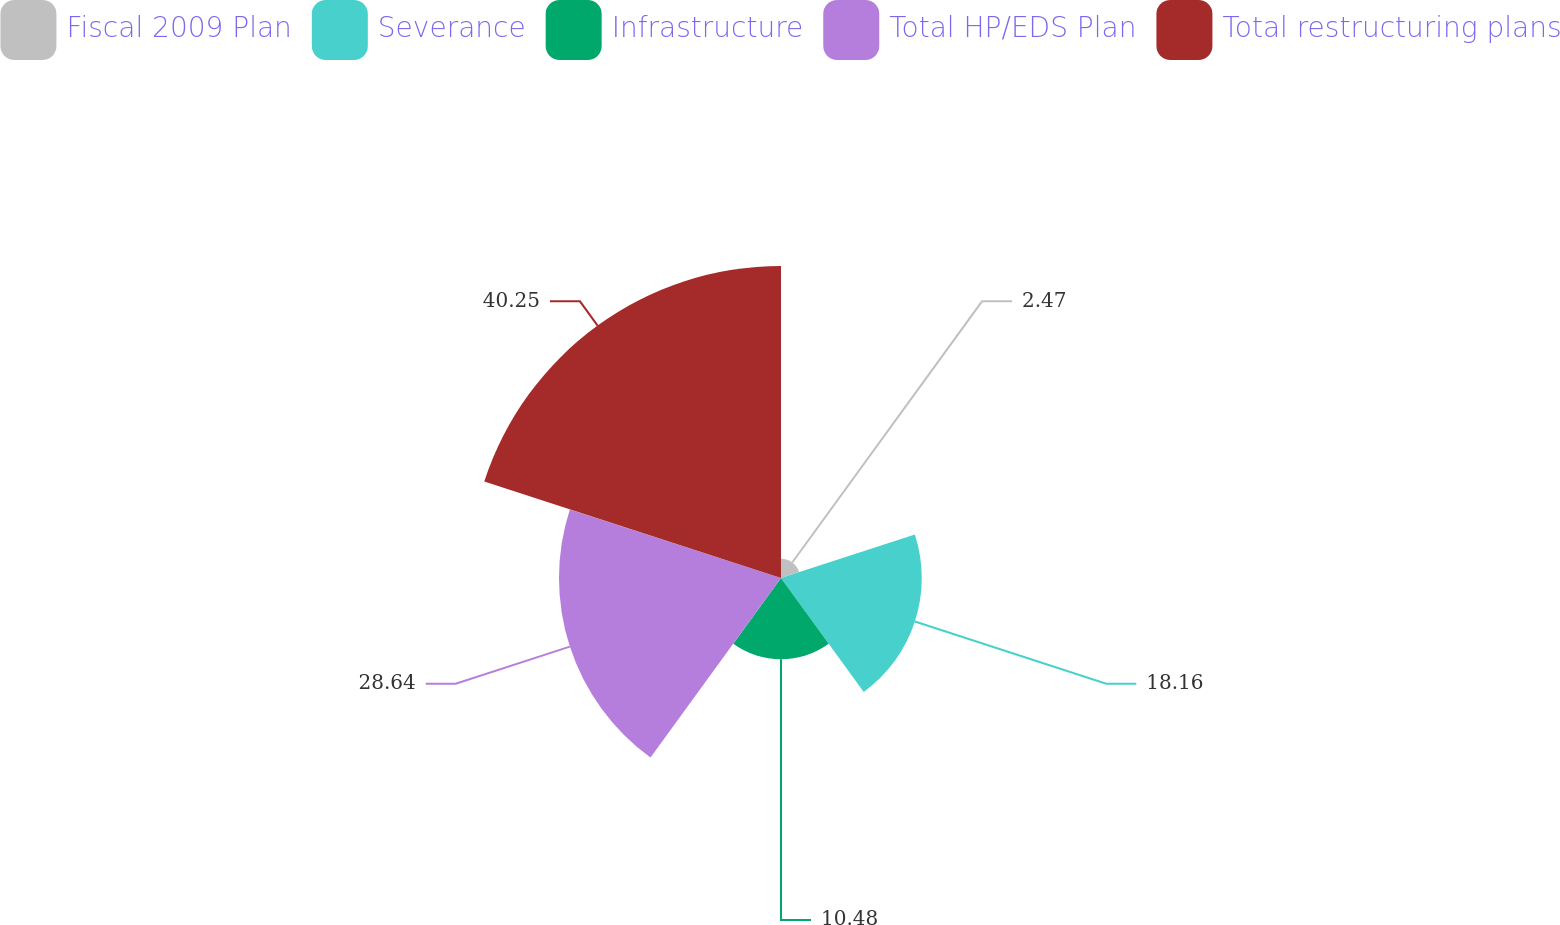Convert chart to OTSL. <chart><loc_0><loc_0><loc_500><loc_500><pie_chart><fcel>Fiscal 2009 Plan<fcel>Severance<fcel>Infrastructure<fcel>Total HP/EDS Plan<fcel>Total restructuring plans<nl><fcel>2.47%<fcel>18.16%<fcel>10.48%<fcel>28.64%<fcel>40.25%<nl></chart> 